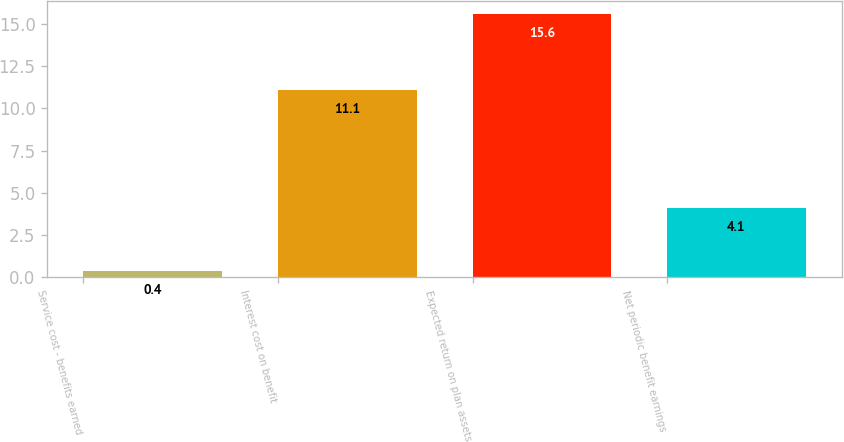Convert chart to OTSL. <chart><loc_0><loc_0><loc_500><loc_500><bar_chart><fcel>Service cost - benefits earned<fcel>Interest cost on benefit<fcel>Expected return on plan assets<fcel>Net periodic benefit earnings<nl><fcel>0.4<fcel>11.1<fcel>15.6<fcel>4.1<nl></chart> 